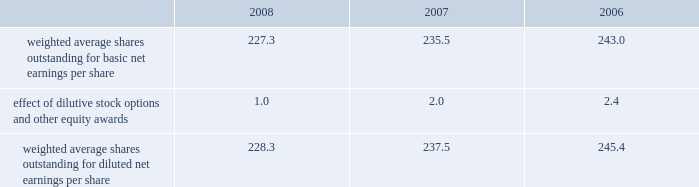Reasonably possible that such matters will be resolved in the next twelve months , but we do not anticipate that the resolution of these matters would result in any material impact on our results of operations or financial position .
Foreign jurisdictions have statutes of limitations generally ranging from 3 to 5 years .
Years still open to examination by foreign tax authorities in major jurisdictions include australia ( 2003 onward ) , canada ( 2002 onward ) , france ( 2006 onward ) , germany ( 2005 onward ) , italy ( 2005 onward ) , japan ( 2002 onward ) , puerto rico ( 2005 onward ) , singapore ( 2003 onward ) , switzerland ( 2006 onward ) and the united kingdom ( 2006 onward ) .
Our tax returns are currently under examination in various foreign jurisdictions .
The most significant foreign tax jurisdiction under examination is the united kingdom .
It is reasonably possible that such audits will be resolved in the next twelve months , but we do not anticipate that the resolution of these audits would result in any material impact on our results of operations or financial position .
13 .
Capital stock and earnings per share we are authorized to issue 250 million shares of preferred stock , none of which were issued or outstanding as of december 31 , 2008 .
The numerator for both basic and diluted earnings per share is net earnings available to common stockholders .
The denominator for basic earnings per share is the weighted average number of common shares outstanding during the period .
The denominator for diluted earnings per share is weighted average shares outstanding adjusted for the effect of dilutive stock options and other equity awards .
The following is a reconciliation of weighted average shares for the basic and diluted share computations for the years ending december 31 ( in millions ) : .
Weighted average shares outstanding for basic net earnings per share 227.3 235.5 243.0 effect of dilutive stock options and other equity awards 1.0 2.0 2.4 weighted average shares outstanding for diluted net earnings per share 228.3 237.5 245.4 for the year ended december 31 , 2008 , an average of 11.2 million options to purchase shares of common stock were not included in the computation of diluted earnings per share as the exercise prices of these options were greater than the average market price of the common stock .
For the years ended december 31 , 2007 and 2006 , an average of 3.1 million and 7.6 million options , respectively , were not included .
During 2008 , we repurchased approximately 10.8 million shares of our common stock at an average price of $ 68.72 per share for a total cash outlay of $ 737.0 million , including commissions .
In april 2008 , we announced that our board of directors authorized a $ 1.25 billion share repurchase program which expires december 31 , 2009 .
Approximately $ 1.13 billion remains authorized under this plan .
14 .
Segment data we design , develop , manufacture and market orthopaedic and dental reconstructive implants , spinal implants , trauma products and related surgical products which include surgical supplies and instruments designed to aid in orthopaedic surgical procedures and post-operation rehabilitation .
We also provide other healthcare-related services .
Revenue related to these services currently represents less than 1 percent of our total net sales .
We manage operations through three major geographic segments 2013 the americas , which is comprised principally of the united states and includes other north , central and south american markets ; europe , which is comprised principally of europe and includes the middle east and africa ; and asia pacific , which is comprised primarily of japan and includes other asian and pacific markets .
This structure is the basis for our reportable segment information discussed below .
Management evaluates operating segment performance based upon segment operating profit exclusive of operating expenses pertaining to global operations and corporate expenses , share-based compensation expense , settlement , certain claims , acquisition , integration and other expenses , inventory step-up , in-process research and development write-offs and intangible asset amortization expense .
Global operations include research , development engineering , medical education , brand management , corporate legal , finance , and human resource functions , and u.s .
And puerto rico-based manufacturing operations and logistics .
Intercompany transactions have been eliminated from segment operating profit .
Management reviews accounts receivable , inventory , property , plant and equipment , goodwill and intangible assets by reportable segment exclusive of u.s and puerto rico-based manufacturing operations and logistics and corporate assets .
Z i m m e r h o l d i n g s , i n c .
2 0 0 8 f o r m 1 0 - k a n n u a l r e p o r t notes to consolidated financial statements ( continued ) %%transmsg*** transmitting job : c48761 pcn : 058000000 ***%%pcmsg|58 |00011|yes|no|02/24/2009 19:25|0|0|page is valid , no graphics -- color : d| .
% (  % ) change of the dilutive effect from 2006-2008? 
Computations: (1 - (1 / 2.4))
Answer: 0.58333. 